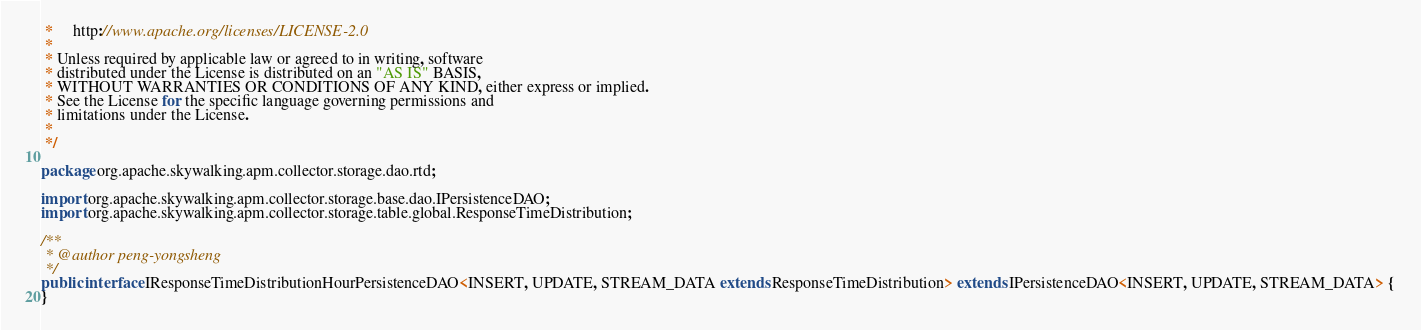Convert code to text. <code><loc_0><loc_0><loc_500><loc_500><_Java_> *     http://www.apache.org/licenses/LICENSE-2.0
 *
 * Unless required by applicable law or agreed to in writing, software
 * distributed under the License is distributed on an "AS IS" BASIS,
 * WITHOUT WARRANTIES OR CONDITIONS OF ANY KIND, either express or implied.
 * See the License for the specific language governing permissions and
 * limitations under the License.
 *
 */

package org.apache.skywalking.apm.collector.storage.dao.rtd;

import org.apache.skywalking.apm.collector.storage.base.dao.IPersistenceDAO;
import org.apache.skywalking.apm.collector.storage.table.global.ResponseTimeDistribution;

/**
 * @author peng-yongsheng
 */
public interface IResponseTimeDistributionHourPersistenceDAO<INSERT, UPDATE, STREAM_DATA extends ResponseTimeDistribution> extends IPersistenceDAO<INSERT, UPDATE, STREAM_DATA> {
}
</code> 